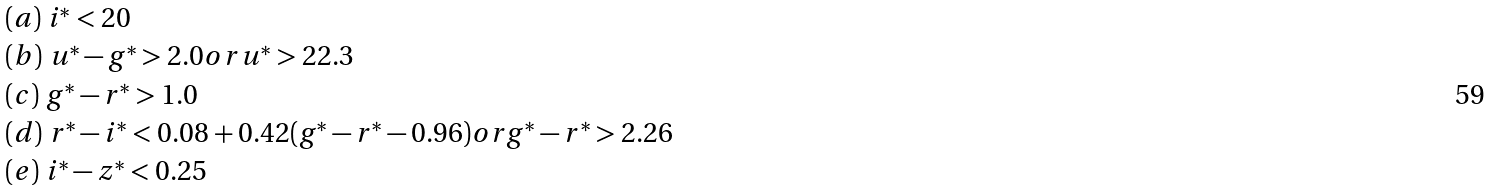Convert formula to latex. <formula><loc_0><loc_0><loc_500><loc_500>\begin{array} { l } ( a ) \ i ^ { * } < 2 0 \\ ( b ) \ u ^ { * } - g ^ { * } > 2 . 0 o r u ^ { * } > 2 2 . 3 \\ ( c ) \ g ^ { * } - r ^ { * } > 1 . 0 \\ ( d ) \ r ^ { * } - i ^ { * } < 0 . 0 8 + 0 . 4 2 ( g ^ { * } - r ^ { * } - 0 . 9 6 ) o r g ^ { * } - r ^ { * } > 2 . 2 6 \\ ( e ) \ i ^ { * } - z ^ { * } < 0 . 2 5 \end{array}</formula> 